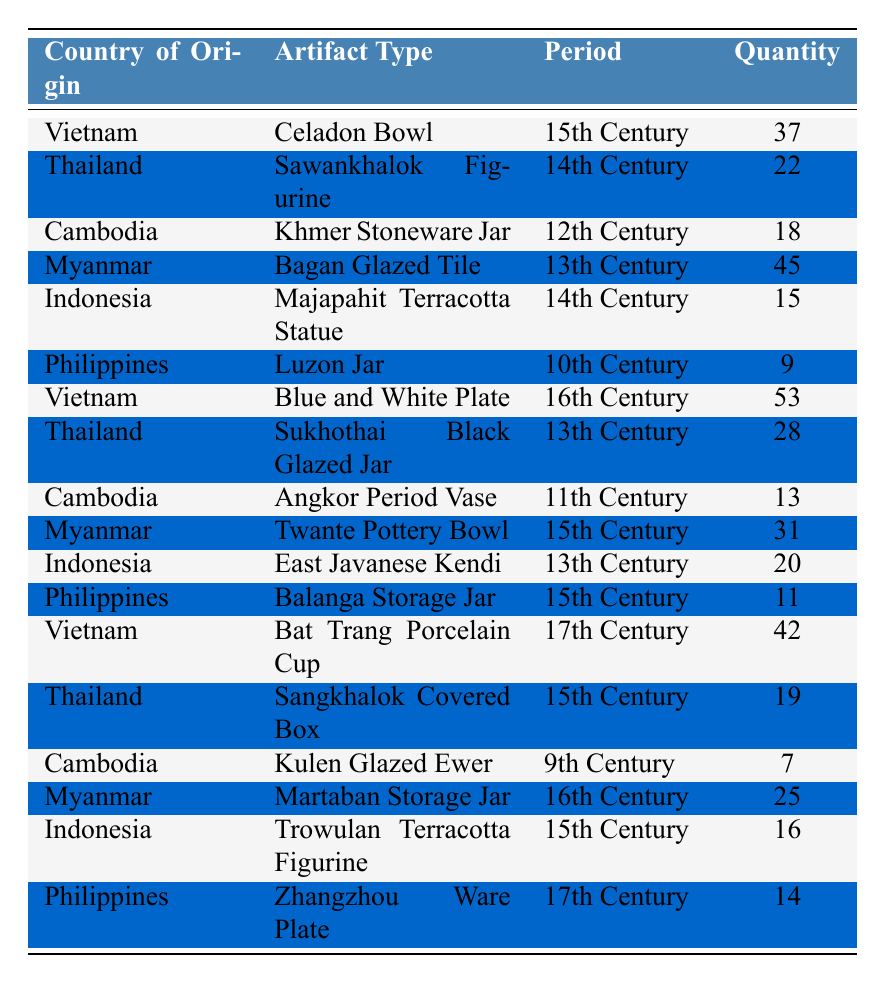What is the most common artifact type listed in the table? To find the most common artifact type, we look at the "Artifact Type" column and tally the occurrences. The Celadon Bowl from Vietnam appears twice, while other types appear less frequently. Thus, Celadon Bowl is the most common.
Answer: Celadon Bowl Which country has the highest quantity of artifacts? By examining the "Quantity" column, we see that Myanmar has the highest quantity: 45 artifacts (Bagan Glazed Tile). Comparing to other countries, this is the maximum quantity.
Answer: Myanmar How many artifacts from Vietnam are included in the table? The table lists two artifacts from Vietnam: the Celadon Bowl (37) and the Blue and White Plate (53). Adding those together gives us a total of 90.
Answer: 90 What is the total quantity of jars (including all types) listed in the table? To calculate the quantity of jars, we refer to the "Artifact Type" column and identify jars: Luzon Jar (9), Khmer Stoneware Jar (18), Sukhothai Black Glazed Jar (28), Balanga Storage Jar (11), and Kulen Glazed Ewer (7). Summing these: 9 + 18 + 28 + 11 + 7 = 73.
Answer: 73 Did Myanmar produce more artifacts than Thailand? Comparing the quantities, Myanmar has 45 artifacts while Thailand has 22. Since 45 > 22, the statement is true.
Answer: Yes How many artifacts are from the 15th century and what is their total quantity? The 15th century artifacts include: Celadon Bowl (37), Twante Pottery Bowl (31), Sangkhalok Covered Box (19), Trowulan Terracotta Figurine (16), and Martaban Storage Jar (25). Adding these quantities gives us: 37 + 31 + 19 + 16 + 25 = 128.
Answer: 128 Which country has the least number of artifacts listed in the table? Upon reviewing the "Quantity" column, the Philippines has the least with a total of 9 artifacts (Luzon Jar).
Answer: Philippines What is the average quantity of artifacts per country in the table? There are 8 countries listed with their quantities: 37, 22, 18, 45, 15, 9, 53, 28, 13, 31, 20, 11, 42, 19, 7, 25, 16, 14. The total is 390 and dividing by 9, the average quantity is 390/18 = 21.67.
Answer: 21.67 Which artifact type has the highest quantity from the 17th century? For the 17th century, the artifact types listed are: Bat Trang Porcelain Cup (42) and Zhangzhou Ware Plate (14). The Bat Trang Porcelain Cup has the highest quantity at 42.
Answer: Bat Trang Porcelain Cup How many artifacts are from Indonesia, and what is their total quantity? The table indicates two artifacts from Indonesia: Majapahit Terracotta Statue (15) and East Javanese Kendi (20), totaling 35 artifacts.
Answer: 35 